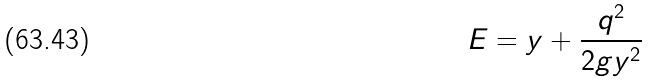Convert formula to latex. <formula><loc_0><loc_0><loc_500><loc_500>E = y + \frac { q ^ { 2 } } { 2 g y ^ { 2 } }</formula> 